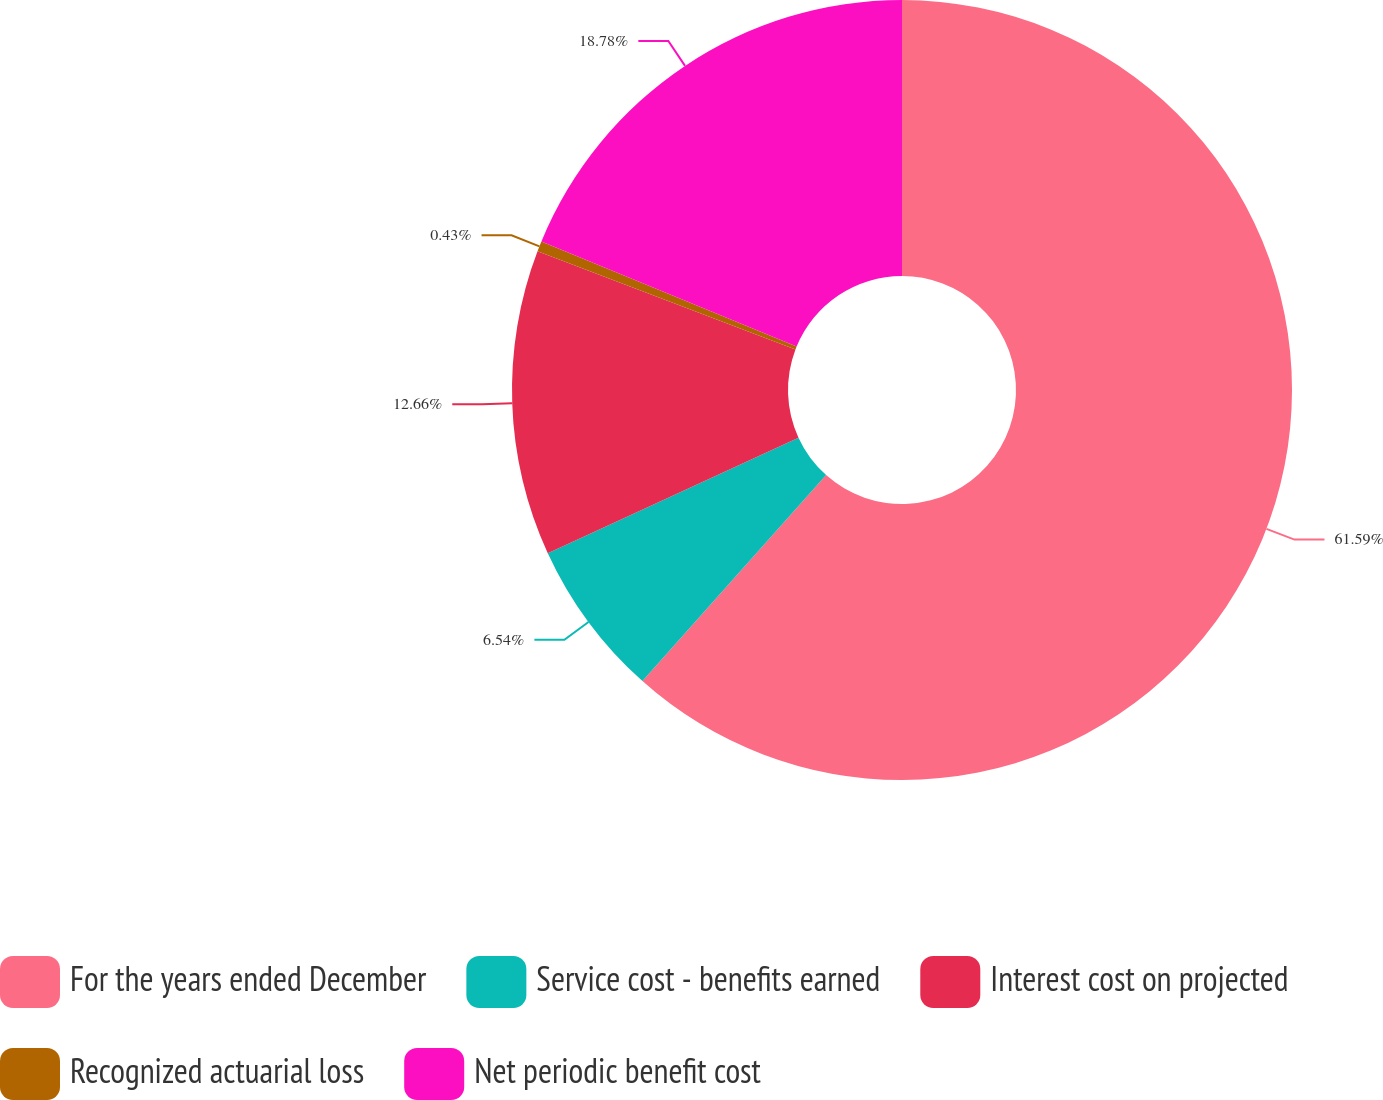Convert chart to OTSL. <chart><loc_0><loc_0><loc_500><loc_500><pie_chart><fcel>For the years ended December<fcel>Service cost - benefits earned<fcel>Interest cost on projected<fcel>Recognized actuarial loss<fcel>Net periodic benefit cost<nl><fcel>61.59%<fcel>6.54%<fcel>12.66%<fcel>0.43%<fcel>18.78%<nl></chart> 